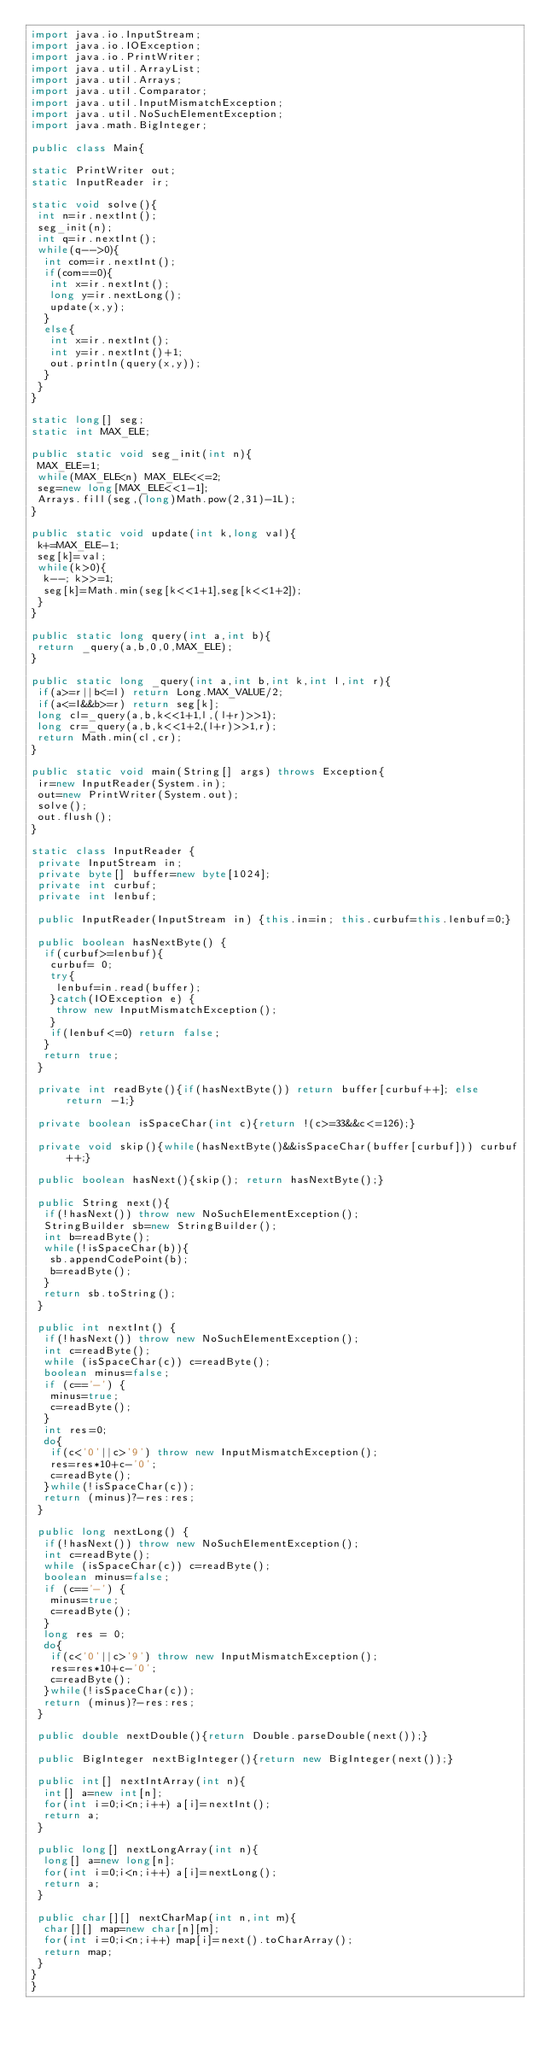<code> <loc_0><loc_0><loc_500><loc_500><_Java_>import java.io.InputStream;
import java.io.IOException;
import java.io.PrintWriter;
import java.util.ArrayList;
import java.util.Arrays;
import java.util.Comparator;
import java.util.InputMismatchException;
import java.util.NoSuchElementException;
import java.math.BigInteger;

public class Main{

static PrintWriter out;
static InputReader ir;

static void solve(){
 int n=ir.nextInt();
 seg_init(n);
 int q=ir.nextInt();
 while(q-->0){
  int com=ir.nextInt();
  if(com==0){
   int x=ir.nextInt();
   long y=ir.nextLong();
   update(x,y);
  }
  else{
   int x=ir.nextInt();
   int y=ir.nextInt()+1;
   out.println(query(x,y));
  }
 }
}

static long[] seg;
static int MAX_ELE;

public static void seg_init(int n){
 MAX_ELE=1;
 while(MAX_ELE<n) MAX_ELE<<=2;
 seg=new long[MAX_ELE<<1-1];
 Arrays.fill(seg,(long)Math.pow(2,31)-1L);
}

public static void update(int k,long val){
 k+=MAX_ELE-1;
 seg[k]=val;
 while(k>0){
  k--; k>>=1;
  seg[k]=Math.min(seg[k<<1+1],seg[k<<1+2]);
 }
}

public static long query(int a,int b){
 return _query(a,b,0,0,MAX_ELE);
}

public static long _query(int a,int b,int k,int l,int r){
 if(a>=r||b<=l) return Long.MAX_VALUE/2;
 if(a<=l&&b>=r) return seg[k];
 long cl=_query(a,b,k<<1+1,l,(l+r)>>1);
 long cr=_query(a,b,k<<1+2,(l+r)>>1,r);
 return Math.min(cl,cr);
}

public static void main(String[] args) throws Exception{
 ir=new InputReader(System.in);
 out=new PrintWriter(System.out);
 solve();
 out.flush();
}

static class InputReader {
 private InputStream in;
 private byte[] buffer=new byte[1024];
 private int curbuf;
 private int lenbuf;

 public InputReader(InputStream in) {this.in=in; this.curbuf=this.lenbuf=0;}
 
 public boolean hasNextByte() {
  if(curbuf>=lenbuf){
   curbuf= 0;
   try{
    lenbuf=in.read(buffer);
   }catch(IOException e) {
    throw new InputMismatchException();
   }
   if(lenbuf<=0) return false;
  }
  return true;
 }

 private int readByte(){if(hasNextByte()) return buffer[curbuf++]; else return -1;}
 
 private boolean isSpaceChar(int c){return !(c>=33&&c<=126);}
 
 private void skip(){while(hasNextByte()&&isSpaceChar(buffer[curbuf])) curbuf++;}
 
 public boolean hasNext(){skip(); return hasNextByte();}
 
 public String next(){
  if(!hasNext()) throw new NoSuchElementException();
  StringBuilder sb=new StringBuilder();
  int b=readByte();
  while(!isSpaceChar(b)){
   sb.appendCodePoint(b);
   b=readByte();
  }
  return sb.toString();
 }
 
 public int nextInt() {
  if(!hasNext()) throw new NoSuchElementException();
  int c=readByte();
  while (isSpaceChar(c)) c=readByte();
  boolean minus=false;
  if (c=='-') {
   minus=true;
   c=readByte();
  }
  int res=0;
  do{
   if(c<'0'||c>'9') throw new InputMismatchException();
   res=res*10+c-'0';
   c=readByte();
  }while(!isSpaceChar(c));
  return (minus)?-res:res;
 }
 
 public long nextLong() {
  if(!hasNext()) throw new NoSuchElementException();
  int c=readByte();
  while (isSpaceChar(c)) c=readByte();
  boolean minus=false;
  if (c=='-') {
   minus=true;
   c=readByte();
  }
  long res = 0;
  do{
   if(c<'0'||c>'9') throw new InputMismatchException();
   res=res*10+c-'0';
   c=readByte();
  }while(!isSpaceChar(c));
  return (minus)?-res:res;
 }

 public double nextDouble(){return Double.parseDouble(next());}

 public BigInteger nextBigInteger(){return new BigInteger(next());}

 public int[] nextIntArray(int n){
  int[] a=new int[n];
  for(int i=0;i<n;i++) a[i]=nextInt();
  return a;
 }

 public long[] nextLongArray(int n){
  long[] a=new long[n];
  for(int i=0;i<n;i++) a[i]=nextLong();
  return a;
 }

 public char[][] nextCharMap(int n,int m){
  char[][] map=new char[n][m];
  for(int i=0;i<n;i++) map[i]=next().toCharArray();
  return map;
 }
}
}</code> 